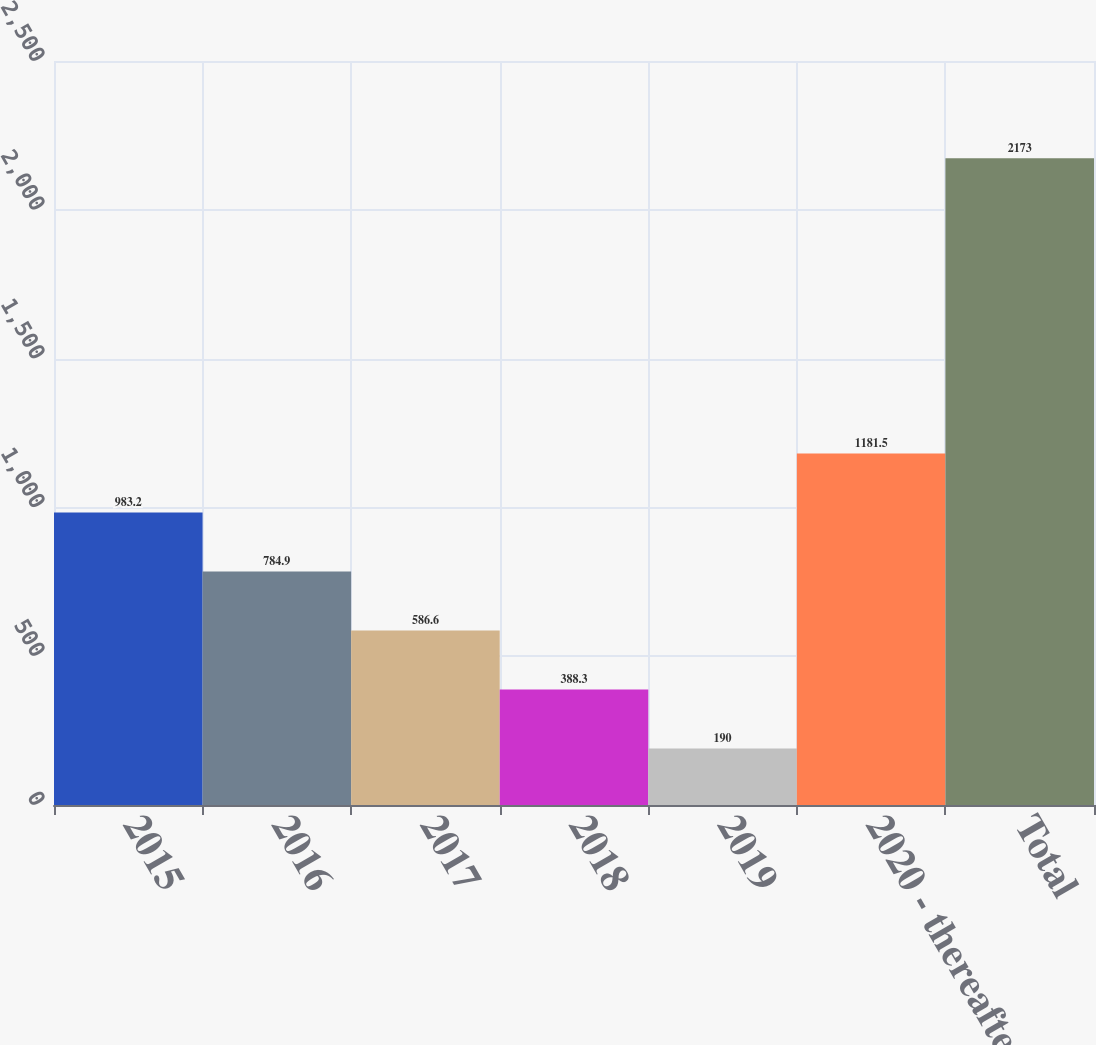<chart> <loc_0><loc_0><loc_500><loc_500><bar_chart><fcel>2015<fcel>2016<fcel>2017<fcel>2018<fcel>2019<fcel>2020 - thereafter<fcel>Total<nl><fcel>983.2<fcel>784.9<fcel>586.6<fcel>388.3<fcel>190<fcel>1181.5<fcel>2173<nl></chart> 